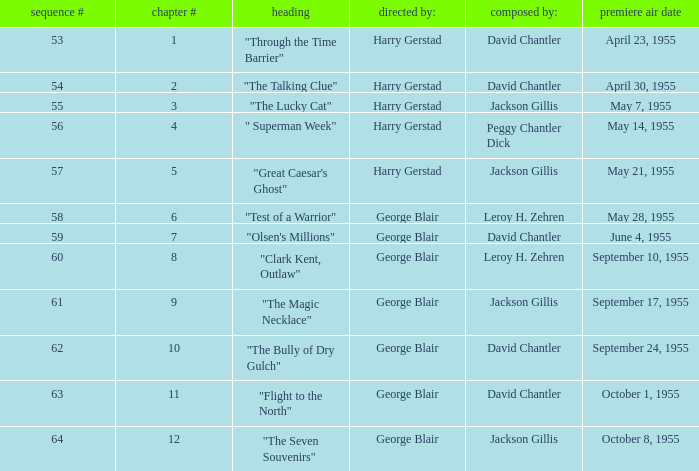What is the lowest number of series? 53.0. 